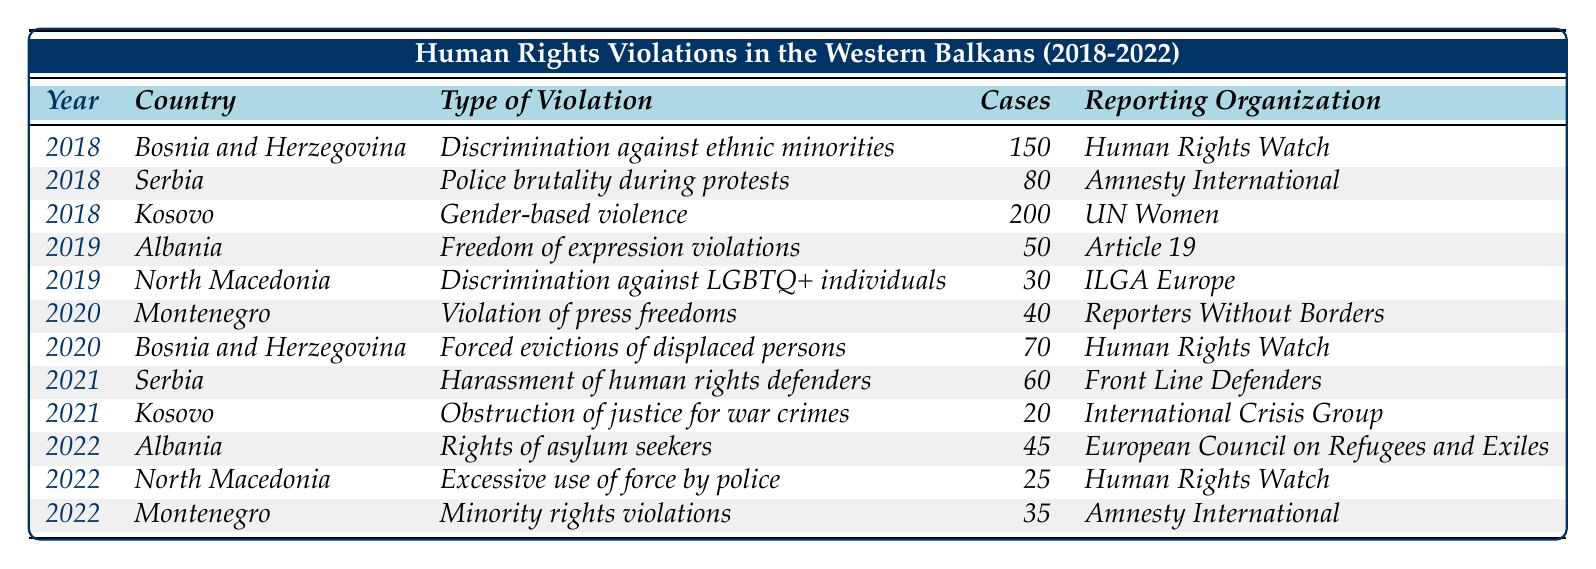What was the total number of human rights violation cases reported in 2018? In 2018, the reported cases are as follows: Bosnia and Herzegovina (150), Serbia (80), and Kosovo (200). Adding these numbers gives 150 + 80 + 200 = 430.
Answer: 430 Which country reported the highest number of human rights violation cases in 2018? Referring to the 2018 data, the cases are: Bosnia and Herzegovina (150), Serbia (80), and Kosovo (200). Kosovo had the highest number with 200 cases.
Answer: Kosovo In which year did North Macedonia report discrimination against LGBTQ+ individuals? North Macedonia reported this violation in 2019, as indicated in the table.
Answer: 2019 What type of violation was reported the least in 2022? The reported cases in 2022 include Albania (45), North Macedonia (25), and Montenegro (35). North Macedonia reported the least with 25 cases.
Answer: Excessive use of force by police How many cases of gender-based violence were reported in Kosovo in 2018? According to the table, Kosovo reported 200 cases of gender-based violence in 2018.
Answer: 200 Which reporting organization highlighted the forced evictions of displaced persons in Bosnia and Herzegovina? The table states that the reporting organization for the forced evictions in Bosnia and Herzegovina is Human Rights Watch.
Answer: Human Rights Watch What was the change in the number of reported human rights violation cases in Kosovo from 2018 to 2021? Kosovo reported 200 cases in 2018 and 20 cases in 2021. The change is calculated as 200 - 20 = 180 cases.
Answer: 180 cases Identify the two countries that reported violations related to minority rights and their respective violation types. The table indicates that Montenegro reported minority rights violations in 2022 and Bosnia and Herzegovina reported discrimination against ethnic minorities in 2018.
Answer: Montenegro (Minority rights violations) and Bosnia and Herzegovina (Discrimination against ethnic minorities) Which country had the highest number of reported cases from 2018 to 2022 and what was the number? Analyzing the entire data set, Kosovo had the highest case count with 200 cases in 2018. None exceeded this in subsequent years.
Answer: 200 cases in Kosovo (2018) Was there an increase or decrease in the number of cases reported for Albania from 2019 to 2022? Albania reported 50 cases in 2019 and 45 cases in 2022. This indicates a decrease of 5 cases.
Answer: Decrease What was the total number of reported human rights violation cases across all countries in 2020? In 2020, the cases reported were: Montenegro (40) and Bosnia and Herzegovina (70). Summing these gives 40 + 70 = 110 cases.
Answer: 110 cases 